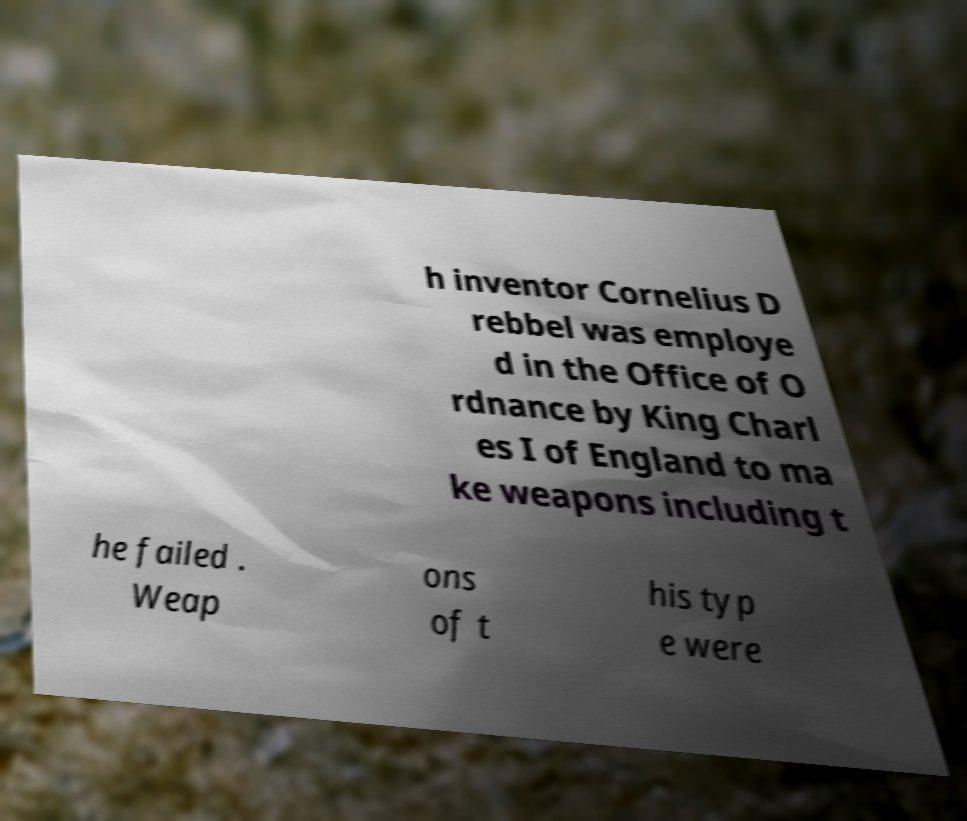Can you accurately transcribe the text from the provided image for me? h inventor Cornelius D rebbel was employe d in the Office of O rdnance by King Charl es I of England to ma ke weapons including t he failed . Weap ons of t his typ e were 